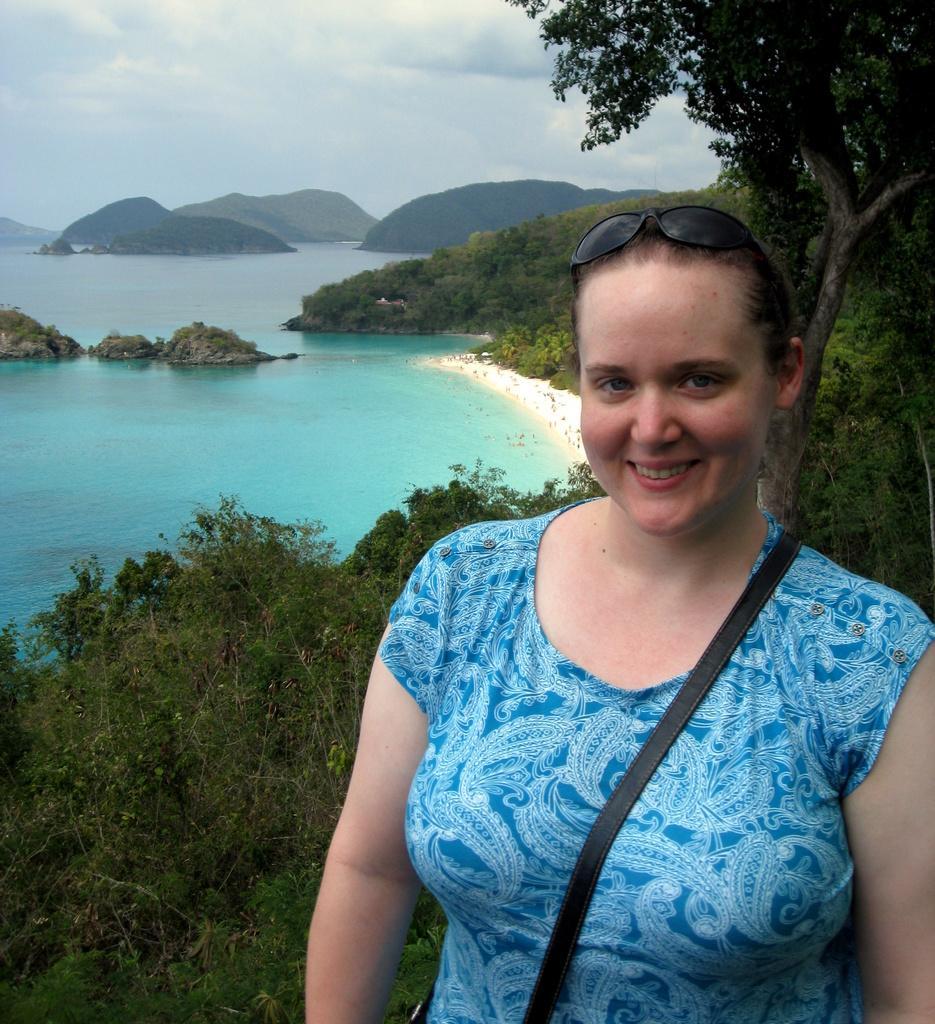In one or two sentences, can you explain what this image depicts? In this image, on the right side, we can see a woman standing and she is smiling, we can see some plants and trees. We can see water and there are some mountains. At the top we can see the sky. 